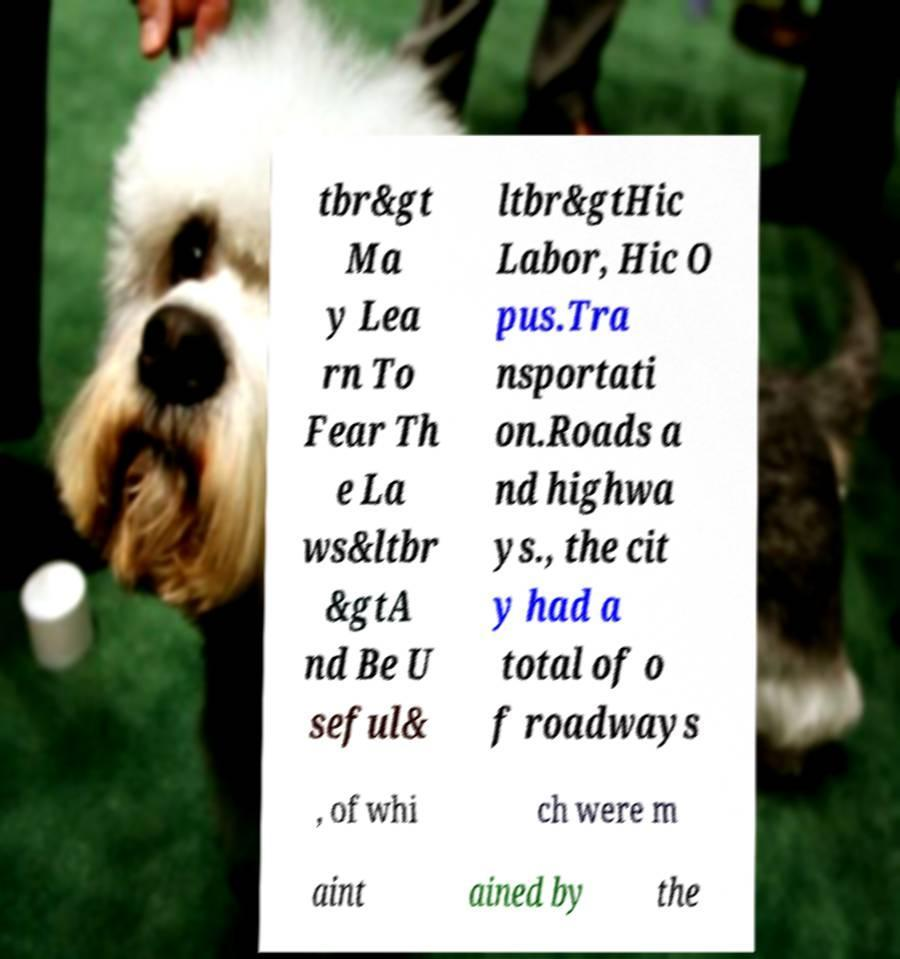What messages or text are displayed in this image? I need them in a readable, typed format. tbr&gt Ma y Lea rn To Fear Th e La ws&ltbr &gtA nd Be U seful& ltbr&gtHic Labor, Hic O pus.Tra nsportati on.Roads a nd highwa ys., the cit y had a total of o f roadways , of whi ch were m aint ained by the 